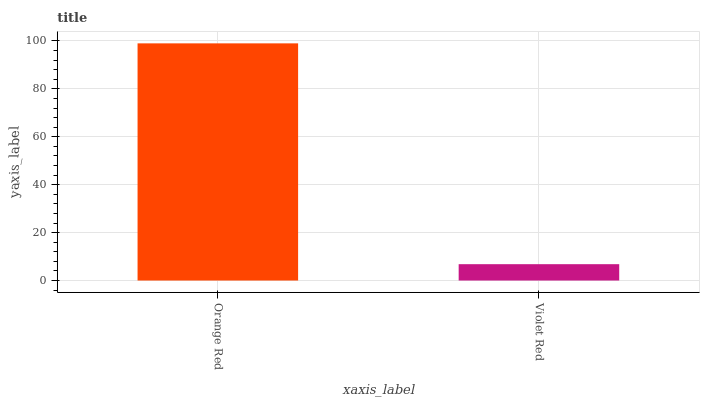Is Violet Red the maximum?
Answer yes or no. No. Is Orange Red greater than Violet Red?
Answer yes or no. Yes. Is Violet Red less than Orange Red?
Answer yes or no. Yes. Is Violet Red greater than Orange Red?
Answer yes or no. No. Is Orange Red less than Violet Red?
Answer yes or no. No. Is Orange Red the high median?
Answer yes or no. Yes. Is Violet Red the low median?
Answer yes or no. Yes. Is Violet Red the high median?
Answer yes or no. No. Is Orange Red the low median?
Answer yes or no. No. 